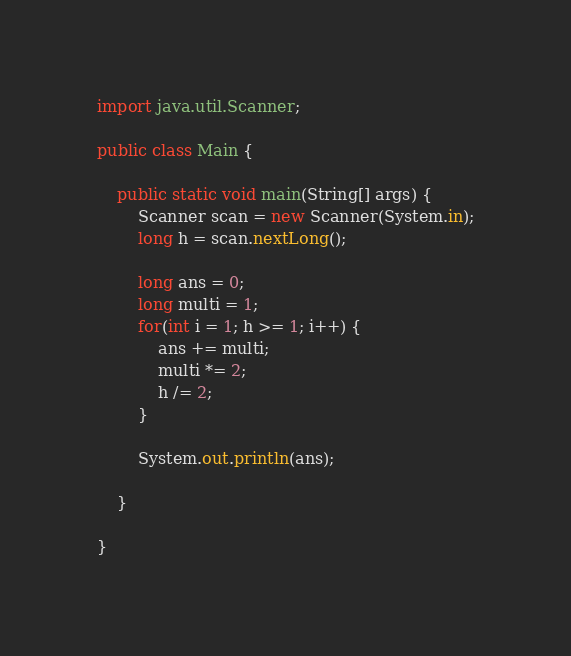Convert code to text. <code><loc_0><loc_0><loc_500><loc_500><_Java_>import java.util.Scanner;

public class Main {

	public static void main(String[] args) {
		Scanner scan = new Scanner(System.in);
		long h = scan.nextLong();

		long ans = 0;
		long multi = 1;
		for(int i = 1; h >= 1; i++) {
			ans += multi;
			multi *= 2;
			h /= 2;
		}

		System.out.println(ans);

	}

}</code> 